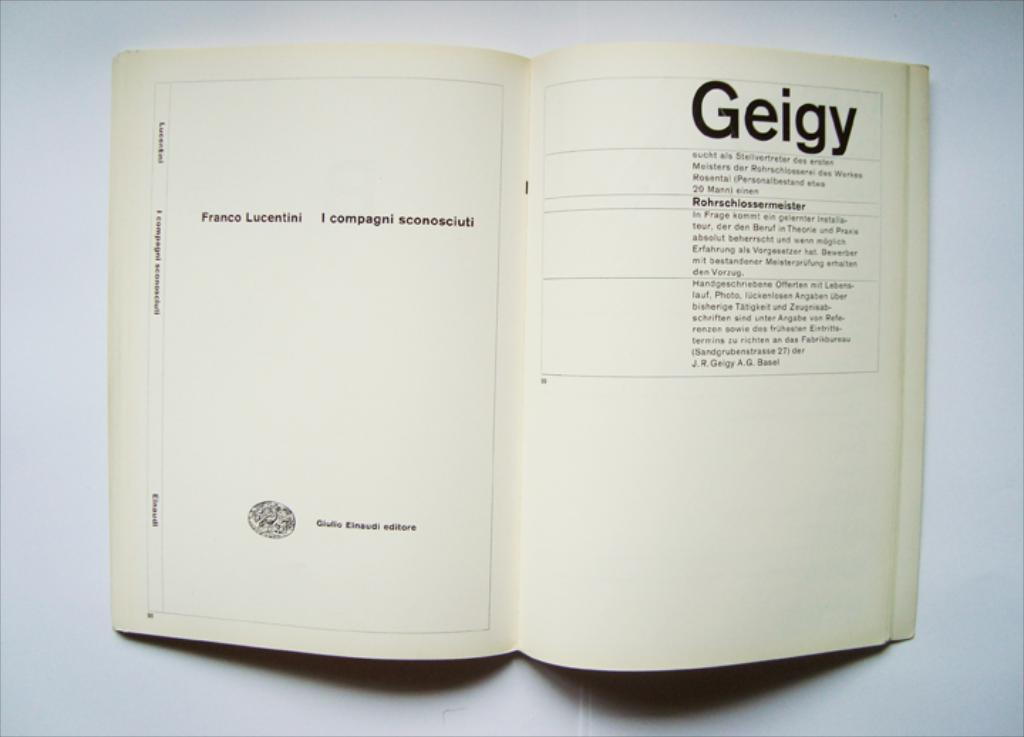<image>
Offer a succinct explanation of the picture presented. A book open to a page titled Geigy. 